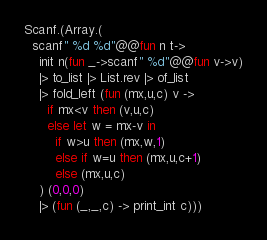Convert code to text. <code><loc_0><loc_0><loc_500><loc_500><_OCaml_>Scanf.(Array.(
  scanf" %d %d"@@fun n t->
    init n(fun _->scanf" %d"@@fun v->v)
    |> to_list |> List.rev |> of_list
    |> fold_left (fun (mx,u,c) v ->
      if mx<v then (v,u,c)
      else let w = mx-v in
        if w>u then (mx,w,1)
        else if w=u then (mx,u,c+1)
        else (mx,u,c)
    ) (0,0,0)
    |> (fun (_,_,c) -> print_int c)))</code> 